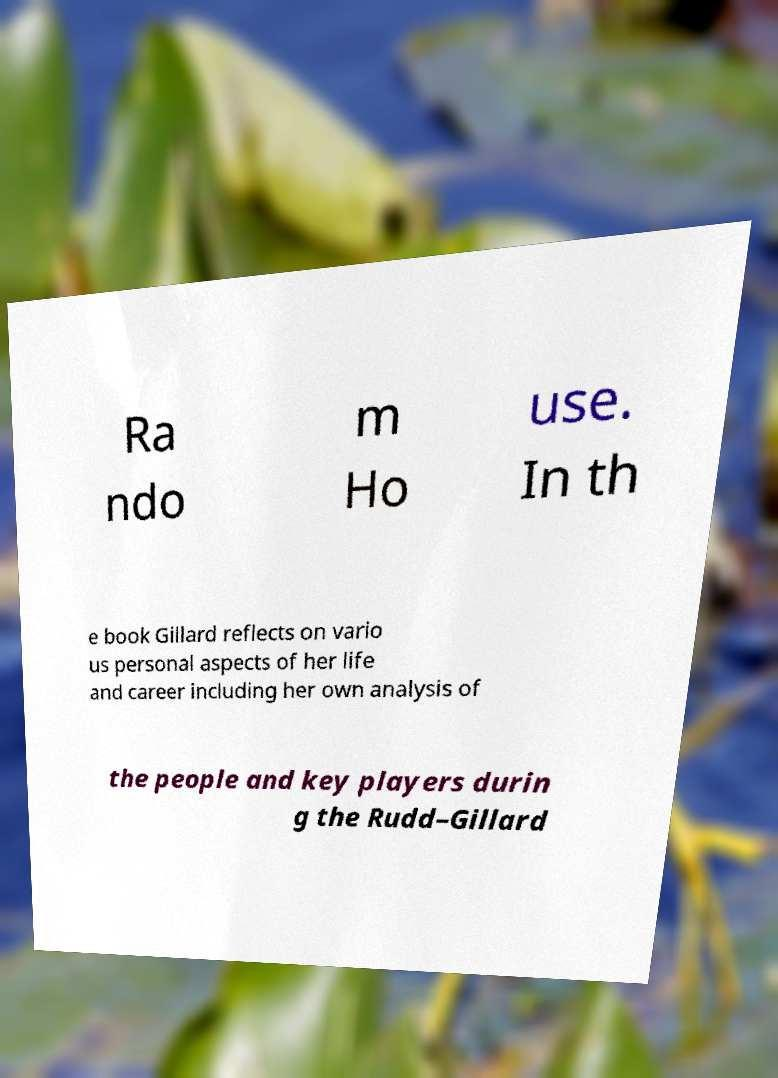Could you assist in decoding the text presented in this image and type it out clearly? Ra ndo m Ho use. In th e book Gillard reflects on vario us personal aspects of her life and career including her own analysis of the people and key players durin g the Rudd–Gillard 